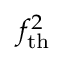Convert formula to latex. <formula><loc_0><loc_0><loc_500><loc_500>f _ { t h } ^ { 2 }</formula> 